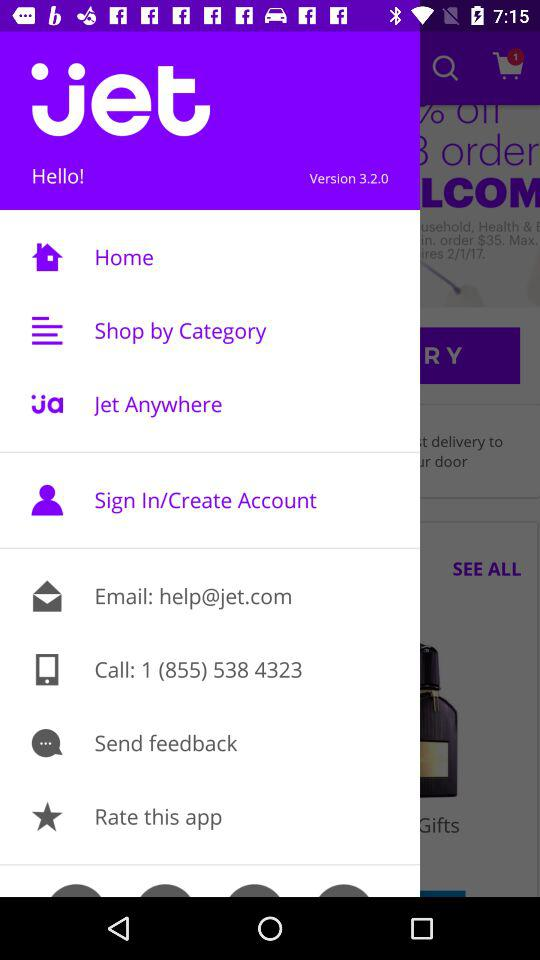What is the contact number? The contact number is 1 (855) 538-4323. 